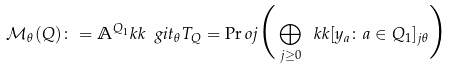<formula> <loc_0><loc_0><loc_500><loc_500>\mathcal { M } _ { \theta } ( Q ) \colon = \mathbb { A } ^ { Q _ { 1 } } _ { \ } k k \ g i t _ { \theta } T _ { Q } = \Pr o j \Big { ( } \bigoplus _ { j \geq 0 } \ k k [ y _ { a } \colon a \in Q _ { 1 } ] _ { j \theta } \Big { ) }</formula> 